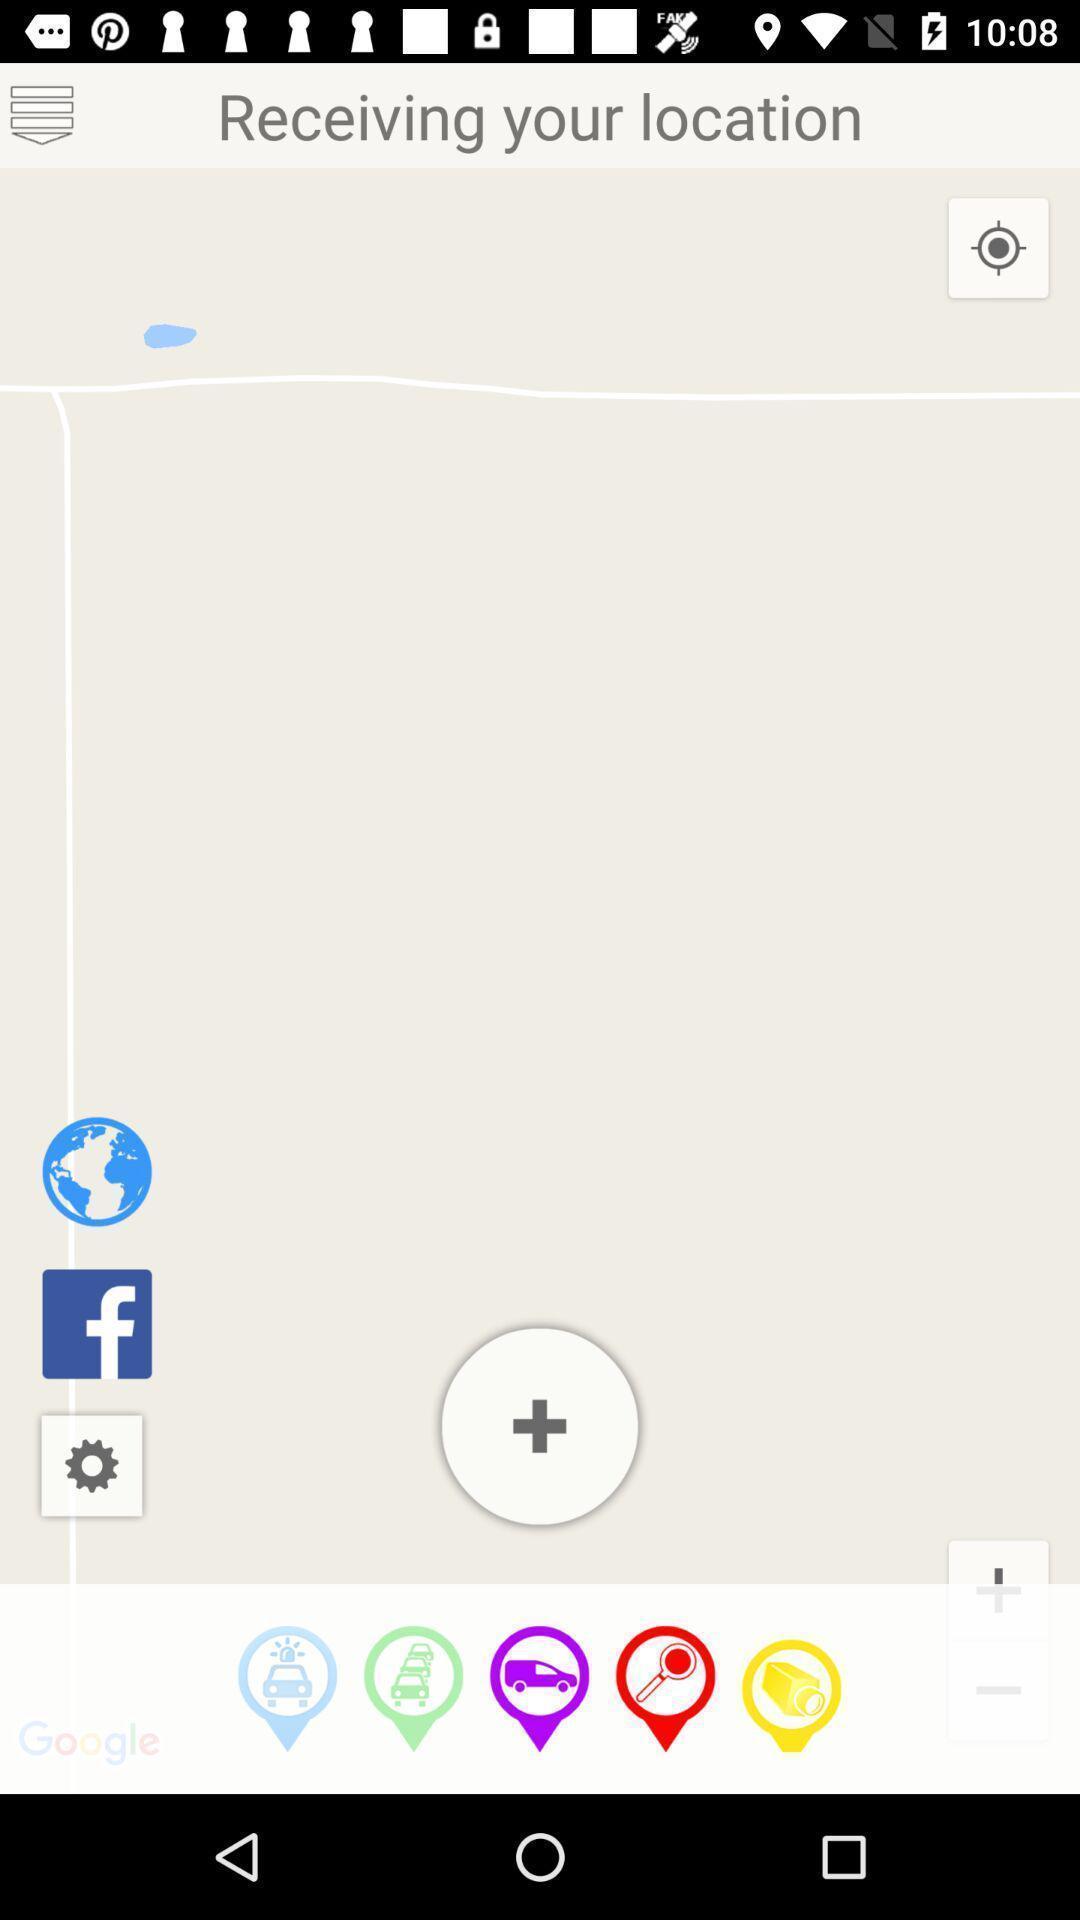What can you discern from this picture? Screen displaying the location page. 